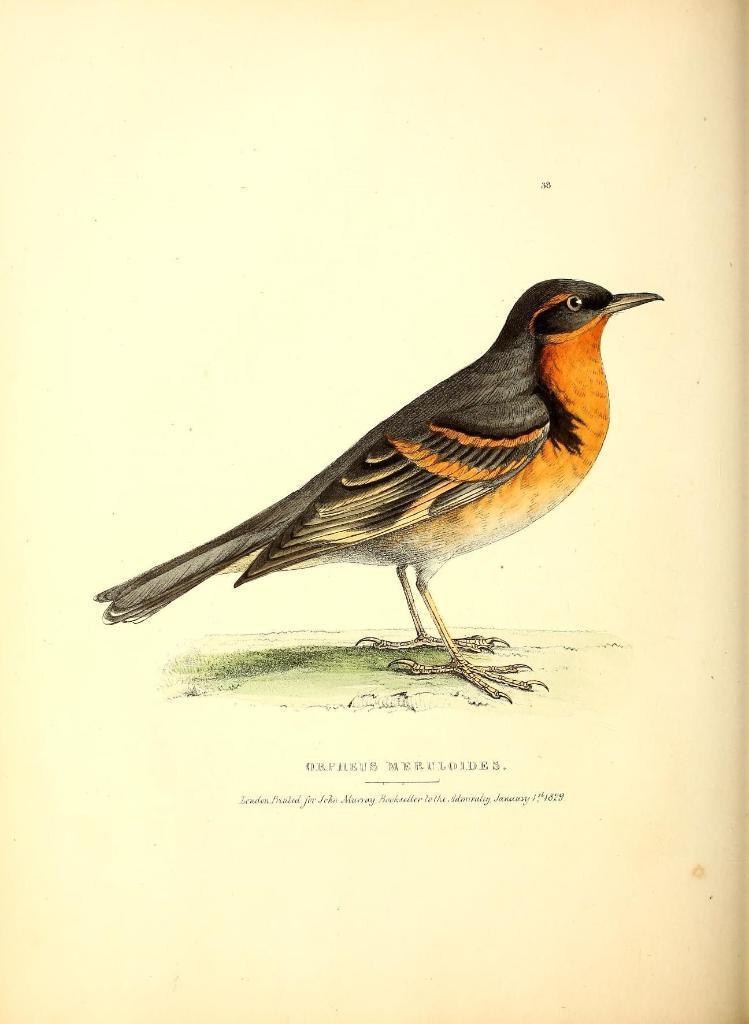In one or two sentences, can you explain what this image depicts? In this image we can see picture of a bird and text written on it. 